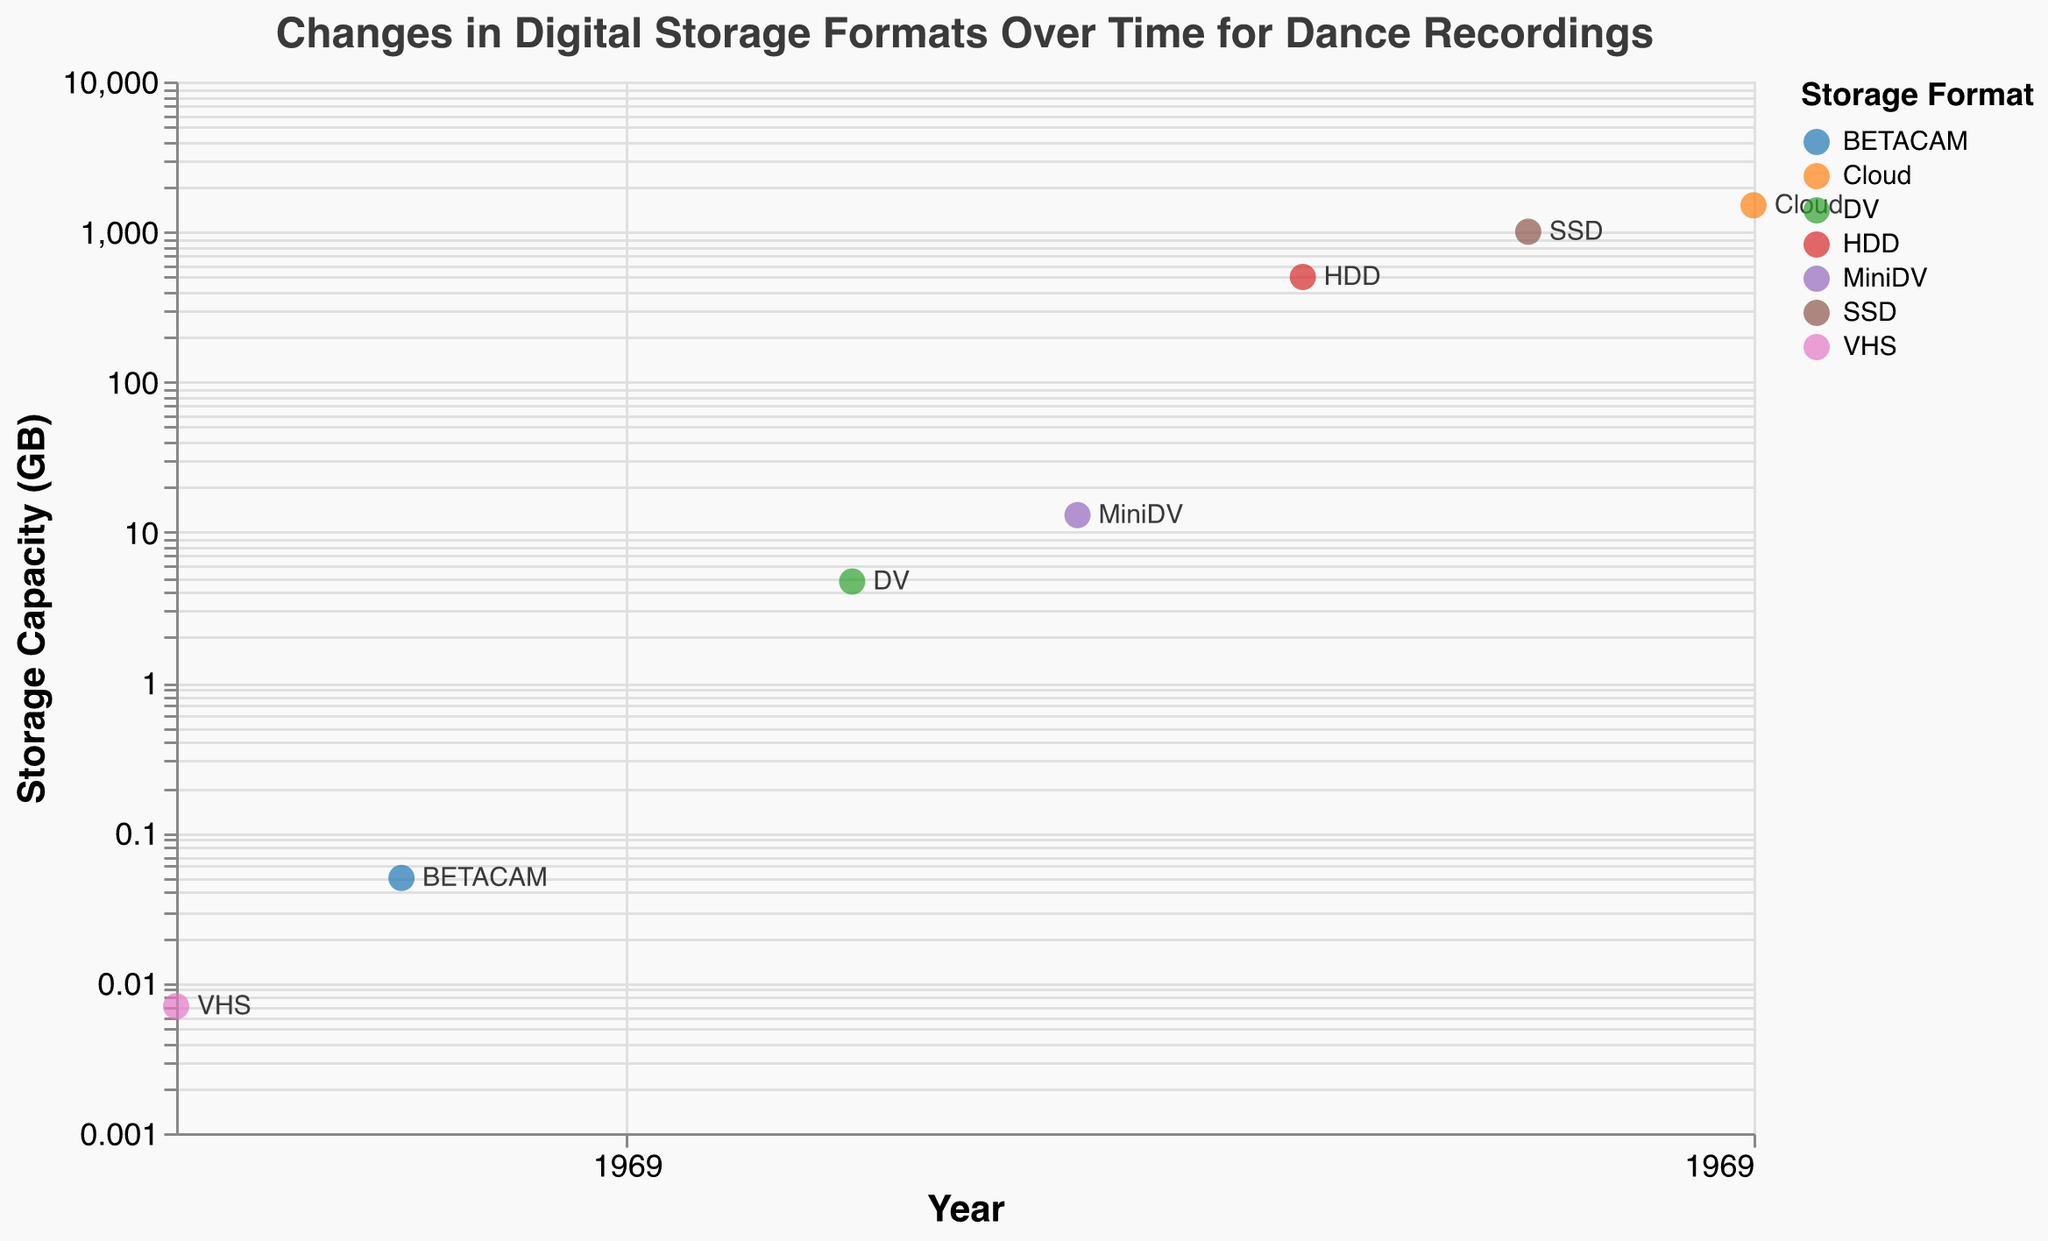What is the main title of the figure? The main title is always prominently displayed at the top of the figure and is intended to provide an overview of what the figure represents.
Answer: Changes in Digital Storage Formats Over Time for Dance Recordings What storage format was used in the year 2000? To find this, you look for the data point corresponding to the year 2000 and check the label next to it.
Answer: DV How many formats are represented in the scatter plot? Look at the legend to count the unique formats listed.
Answer: Seven Which year saw the introduction of SSD storage for dance recordings? Identify the data point where the format is labeled "SSD" and note the year associated with it.
Answer: 2015 What is the storage capacity difference between the formats used in 1985 and 2010? Find the storage capacities for the years 1985 and 2010 and calculate the difference: 500 GB (HDD) - 0.007 GB (VHS).
Answer: 499.993 GB Which format has the highest storage capacity and what is its value? Inspect the y-axis values to find the data point with the highest storage capacity and note its format and value.
Answer: Cloud, 1500 GB How has the storage capacity for dance recordings changed from 2000 to 2020? Compare the storage capacities over these years to analyze the trend.
Answer: Increased from 4.7 GB to 1500 GB What is the trend in storage capacity over time? Examine the y-axis values and their corresponding years to identify the overall pattern or trend in storage capacity.
Answer: Increasing Which organization was using HDDs for storing dance recordings, and which recording was associated with it? Locate the data point labeled "HDD" and check the tooltip or label for the organization and recording information.
Answer: University of Surrey - National Resource Centre for Dance, Anne Teresa De Keersmaeker's Rosas danst Rosas What color is used to represent BETACAM in the plot? Refer to the legend to find the color associated with the BETACAM format.
Answer: Specific color indicated in the plot's legend 